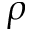Convert formula to latex. <formula><loc_0><loc_0><loc_500><loc_500>\rho</formula> 